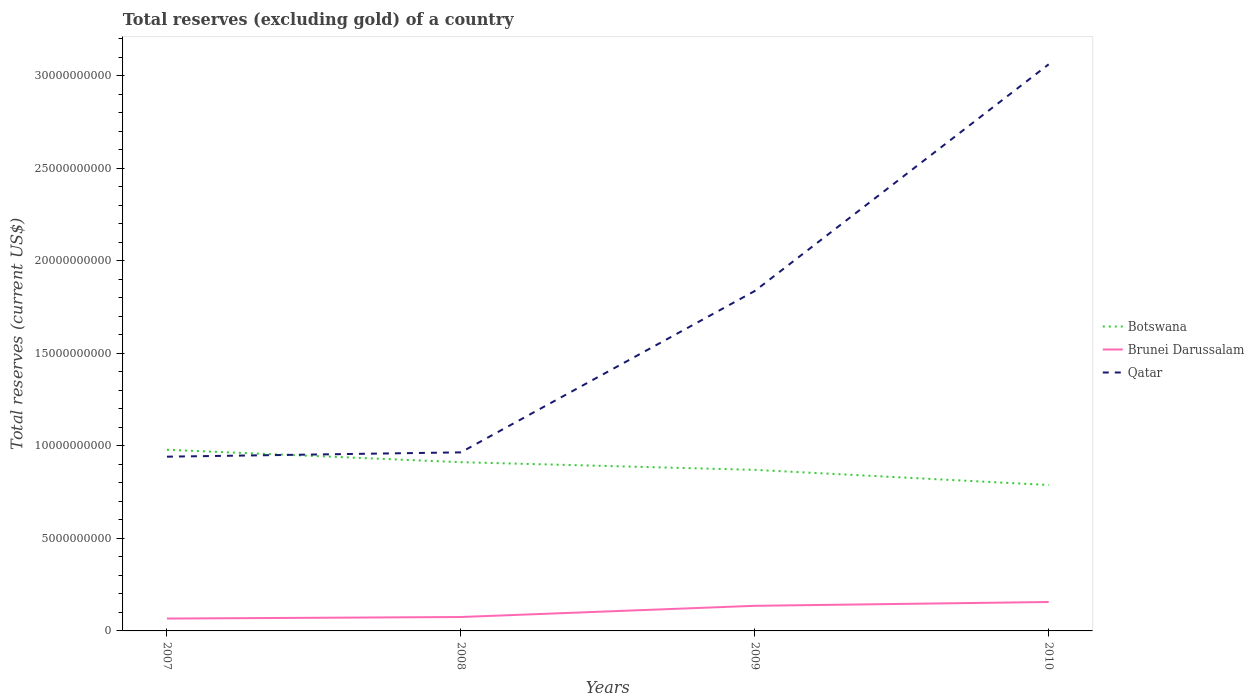How many different coloured lines are there?
Your answer should be compact. 3. Does the line corresponding to Qatar intersect with the line corresponding to Brunei Darussalam?
Offer a terse response. No. Across all years, what is the maximum total reserves (excluding gold) in Brunei Darussalam?
Offer a very short reply. 6.67e+08. In which year was the total reserves (excluding gold) in Botswana maximum?
Give a very brief answer. 2010. What is the total total reserves (excluding gold) in Qatar in the graph?
Your answer should be very brief. -8.72e+09. What is the difference between the highest and the second highest total reserves (excluding gold) in Qatar?
Provide a short and direct response. 2.12e+1. What is the difference between the highest and the lowest total reserves (excluding gold) in Qatar?
Your answer should be compact. 2. How many lines are there?
Make the answer very short. 3. Does the graph contain any zero values?
Your response must be concise. No. Does the graph contain grids?
Provide a succinct answer. No. What is the title of the graph?
Give a very brief answer. Total reserves (excluding gold) of a country. What is the label or title of the Y-axis?
Give a very brief answer. Total reserves (current US$). What is the Total reserves (current US$) of Botswana in 2007?
Make the answer very short. 9.79e+09. What is the Total reserves (current US$) of Brunei Darussalam in 2007?
Offer a very short reply. 6.67e+08. What is the Total reserves (current US$) in Qatar in 2007?
Make the answer very short. 9.42e+09. What is the Total reserves (current US$) of Botswana in 2008?
Make the answer very short. 9.12e+09. What is the Total reserves (current US$) in Brunei Darussalam in 2008?
Keep it short and to the point. 7.51e+08. What is the Total reserves (current US$) of Qatar in 2008?
Your answer should be very brief. 9.65e+09. What is the Total reserves (current US$) of Botswana in 2009?
Offer a terse response. 8.70e+09. What is the Total reserves (current US$) in Brunei Darussalam in 2009?
Offer a very short reply. 1.36e+09. What is the Total reserves (current US$) in Qatar in 2009?
Give a very brief answer. 1.84e+1. What is the Total reserves (current US$) of Botswana in 2010?
Your response must be concise. 7.89e+09. What is the Total reserves (current US$) of Brunei Darussalam in 2010?
Offer a very short reply. 1.56e+09. What is the Total reserves (current US$) in Qatar in 2010?
Your answer should be compact. 3.06e+1. Across all years, what is the maximum Total reserves (current US$) in Botswana?
Give a very brief answer. 9.79e+09. Across all years, what is the maximum Total reserves (current US$) of Brunei Darussalam?
Provide a succinct answer. 1.56e+09. Across all years, what is the maximum Total reserves (current US$) of Qatar?
Your answer should be compact. 3.06e+1. Across all years, what is the minimum Total reserves (current US$) of Botswana?
Offer a very short reply. 7.89e+09. Across all years, what is the minimum Total reserves (current US$) of Brunei Darussalam?
Keep it short and to the point. 6.67e+08. Across all years, what is the minimum Total reserves (current US$) in Qatar?
Provide a succinct answer. 9.42e+09. What is the total Total reserves (current US$) in Botswana in the graph?
Provide a succinct answer. 3.55e+1. What is the total Total reserves (current US$) in Brunei Darussalam in the graph?
Ensure brevity in your answer.  4.34e+09. What is the total Total reserves (current US$) of Qatar in the graph?
Provide a short and direct response. 6.81e+1. What is the difference between the Total reserves (current US$) in Botswana in 2007 and that in 2008?
Ensure brevity in your answer.  6.71e+08. What is the difference between the Total reserves (current US$) in Brunei Darussalam in 2007 and that in 2008?
Offer a very short reply. -8.37e+07. What is the difference between the Total reserves (current US$) of Qatar in 2007 and that in 2008?
Offer a very short reply. -2.33e+08. What is the difference between the Total reserves (current US$) of Botswana in 2007 and that in 2009?
Keep it short and to the point. 1.09e+09. What is the difference between the Total reserves (current US$) of Brunei Darussalam in 2007 and that in 2009?
Your answer should be compact. -6.90e+08. What is the difference between the Total reserves (current US$) of Qatar in 2007 and that in 2009?
Offer a very short reply. -8.95e+09. What is the difference between the Total reserves (current US$) in Botswana in 2007 and that in 2010?
Provide a succinct answer. 1.90e+09. What is the difference between the Total reserves (current US$) of Brunei Darussalam in 2007 and that in 2010?
Give a very brief answer. -8.96e+08. What is the difference between the Total reserves (current US$) in Qatar in 2007 and that in 2010?
Make the answer very short. -2.12e+1. What is the difference between the Total reserves (current US$) of Botswana in 2008 and that in 2009?
Provide a short and direct response. 4.15e+08. What is the difference between the Total reserves (current US$) in Brunei Darussalam in 2008 and that in 2009?
Offer a terse response. -6.06e+08. What is the difference between the Total reserves (current US$) in Qatar in 2008 and that in 2009?
Make the answer very short. -8.72e+09. What is the difference between the Total reserves (current US$) of Botswana in 2008 and that in 2010?
Ensure brevity in your answer.  1.23e+09. What is the difference between the Total reserves (current US$) in Brunei Darussalam in 2008 and that in 2010?
Make the answer very short. -8.12e+08. What is the difference between the Total reserves (current US$) of Qatar in 2008 and that in 2010?
Your answer should be compact. -2.10e+1. What is the difference between the Total reserves (current US$) of Botswana in 2009 and that in 2010?
Provide a succinct answer. 8.19e+08. What is the difference between the Total reserves (current US$) in Brunei Darussalam in 2009 and that in 2010?
Your response must be concise. -2.06e+08. What is the difference between the Total reserves (current US$) of Qatar in 2009 and that in 2010?
Give a very brief answer. -1.23e+1. What is the difference between the Total reserves (current US$) of Botswana in 2007 and the Total reserves (current US$) of Brunei Darussalam in 2008?
Give a very brief answer. 9.04e+09. What is the difference between the Total reserves (current US$) in Botswana in 2007 and the Total reserves (current US$) in Qatar in 2008?
Your answer should be very brief. 1.40e+08. What is the difference between the Total reserves (current US$) in Brunei Darussalam in 2007 and the Total reserves (current US$) in Qatar in 2008?
Provide a short and direct response. -8.98e+09. What is the difference between the Total reserves (current US$) in Botswana in 2007 and the Total reserves (current US$) in Brunei Darussalam in 2009?
Give a very brief answer. 8.43e+09. What is the difference between the Total reserves (current US$) of Botswana in 2007 and the Total reserves (current US$) of Qatar in 2009?
Your answer should be very brief. -8.58e+09. What is the difference between the Total reserves (current US$) in Brunei Darussalam in 2007 and the Total reserves (current US$) in Qatar in 2009?
Keep it short and to the point. -1.77e+1. What is the difference between the Total reserves (current US$) in Botswana in 2007 and the Total reserves (current US$) in Brunei Darussalam in 2010?
Provide a succinct answer. 8.23e+09. What is the difference between the Total reserves (current US$) in Botswana in 2007 and the Total reserves (current US$) in Qatar in 2010?
Offer a terse response. -2.08e+1. What is the difference between the Total reserves (current US$) in Brunei Darussalam in 2007 and the Total reserves (current US$) in Qatar in 2010?
Make the answer very short. -3.00e+1. What is the difference between the Total reserves (current US$) in Botswana in 2008 and the Total reserves (current US$) in Brunei Darussalam in 2009?
Offer a very short reply. 7.76e+09. What is the difference between the Total reserves (current US$) of Botswana in 2008 and the Total reserves (current US$) of Qatar in 2009?
Give a very brief answer. -9.25e+09. What is the difference between the Total reserves (current US$) of Brunei Darussalam in 2008 and the Total reserves (current US$) of Qatar in 2009?
Offer a very short reply. -1.76e+1. What is the difference between the Total reserves (current US$) in Botswana in 2008 and the Total reserves (current US$) in Brunei Darussalam in 2010?
Give a very brief answer. 7.56e+09. What is the difference between the Total reserves (current US$) of Botswana in 2008 and the Total reserves (current US$) of Qatar in 2010?
Offer a very short reply. -2.15e+1. What is the difference between the Total reserves (current US$) in Brunei Darussalam in 2008 and the Total reserves (current US$) in Qatar in 2010?
Give a very brief answer. -2.99e+1. What is the difference between the Total reserves (current US$) of Botswana in 2009 and the Total reserves (current US$) of Brunei Darussalam in 2010?
Your answer should be compact. 7.14e+09. What is the difference between the Total reserves (current US$) in Botswana in 2009 and the Total reserves (current US$) in Qatar in 2010?
Provide a succinct answer. -2.19e+1. What is the difference between the Total reserves (current US$) of Brunei Darussalam in 2009 and the Total reserves (current US$) of Qatar in 2010?
Ensure brevity in your answer.  -2.93e+1. What is the average Total reserves (current US$) of Botswana per year?
Provide a short and direct response. 8.87e+09. What is the average Total reserves (current US$) in Brunei Darussalam per year?
Provide a short and direct response. 1.08e+09. What is the average Total reserves (current US$) of Qatar per year?
Make the answer very short. 1.70e+1. In the year 2007, what is the difference between the Total reserves (current US$) of Botswana and Total reserves (current US$) of Brunei Darussalam?
Your answer should be very brief. 9.12e+09. In the year 2007, what is the difference between the Total reserves (current US$) in Botswana and Total reserves (current US$) in Qatar?
Keep it short and to the point. 3.73e+08. In the year 2007, what is the difference between the Total reserves (current US$) in Brunei Darussalam and Total reserves (current US$) in Qatar?
Keep it short and to the point. -8.75e+09. In the year 2008, what is the difference between the Total reserves (current US$) of Botswana and Total reserves (current US$) of Brunei Darussalam?
Provide a succinct answer. 8.37e+09. In the year 2008, what is the difference between the Total reserves (current US$) in Botswana and Total reserves (current US$) in Qatar?
Provide a succinct answer. -5.31e+08. In the year 2008, what is the difference between the Total reserves (current US$) in Brunei Darussalam and Total reserves (current US$) in Qatar?
Provide a short and direct response. -8.90e+09. In the year 2009, what is the difference between the Total reserves (current US$) of Botswana and Total reserves (current US$) of Brunei Darussalam?
Your answer should be compact. 7.35e+09. In the year 2009, what is the difference between the Total reserves (current US$) of Botswana and Total reserves (current US$) of Qatar?
Give a very brief answer. -9.67e+09. In the year 2009, what is the difference between the Total reserves (current US$) of Brunei Darussalam and Total reserves (current US$) of Qatar?
Provide a succinct answer. -1.70e+1. In the year 2010, what is the difference between the Total reserves (current US$) of Botswana and Total reserves (current US$) of Brunei Darussalam?
Offer a terse response. 6.32e+09. In the year 2010, what is the difference between the Total reserves (current US$) in Botswana and Total reserves (current US$) in Qatar?
Provide a short and direct response. -2.27e+1. In the year 2010, what is the difference between the Total reserves (current US$) in Brunei Darussalam and Total reserves (current US$) in Qatar?
Your answer should be very brief. -2.91e+1. What is the ratio of the Total reserves (current US$) in Botswana in 2007 to that in 2008?
Provide a short and direct response. 1.07. What is the ratio of the Total reserves (current US$) in Brunei Darussalam in 2007 to that in 2008?
Your response must be concise. 0.89. What is the ratio of the Total reserves (current US$) in Qatar in 2007 to that in 2008?
Your response must be concise. 0.98. What is the ratio of the Total reserves (current US$) in Botswana in 2007 to that in 2009?
Offer a very short reply. 1.12. What is the ratio of the Total reserves (current US$) in Brunei Darussalam in 2007 to that in 2009?
Give a very brief answer. 0.49. What is the ratio of the Total reserves (current US$) in Qatar in 2007 to that in 2009?
Offer a terse response. 0.51. What is the ratio of the Total reserves (current US$) in Botswana in 2007 to that in 2010?
Your response must be concise. 1.24. What is the ratio of the Total reserves (current US$) of Brunei Darussalam in 2007 to that in 2010?
Give a very brief answer. 0.43. What is the ratio of the Total reserves (current US$) in Qatar in 2007 to that in 2010?
Your answer should be very brief. 0.31. What is the ratio of the Total reserves (current US$) in Botswana in 2008 to that in 2009?
Make the answer very short. 1.05. What is the ratio of the Total reserves (current US$) in Brunei Darussalam in 2008 to that in 2009?
Ensure brevity in your answer.  0.55. What is the ratio of the Total reserves (current US$) in Qatar in 2008 to that in 2009?
Your answer should be very brief. 0.53. What is the ratio of the Total reserves (current US$) of Botswana in 2008 to that in 2010?
Offer a terse response. 1.16. What is the ratio of the Total reserves (current US$) in Brunei Darussalam in 2008 to that in 2010?
Offer a terse response. 0.48. What is the ratio of the Total reserves (current US$) in Qatar in 2008 to that in 2010?
Give a very brief answer. 0.32. What is the ratio of the Total reserves (current US$) in Botswana in 2009 to that in 2010?
Ensure brevity in your answer.  1.1. What is the ratio of the Total reserves (current US$) in Brunei Darussalam in 2009 to that in 2010?
Your answer should be compact. 0.87. What is the ratio of the Total reserves (current US$) in Qatar in 2009 to that in 2010?
Make the answer very short. 0.6. What is the difference between the highest and the second highest Total reserves (current US$) of Botswana?
Ensure brevity in your answer.  6.71e+08. What is the difference between the highest and the second highest Total reserves (current US$) in Brunei Darussalam?
Keep it short and to the point. 2.06e+08. What is the difference between the highest and the second highest Total reserves (current US$) of Qatar?
Keep it short and to the point. 1.23e+1. What is the difference between the highest and the lowest Total reserves (current US$) of Botswana?
Your response must be concise. 1.90e+09. What is the difference between the highest and the lowest Total reserves (current US$) of Brunei Darussalam?
Make the answer very short. 8.96e+08. What is the difference between the highest and the lowest Total reserves (current US$) in Qatar?
Provide a short and direct response. 2.12e+1. 